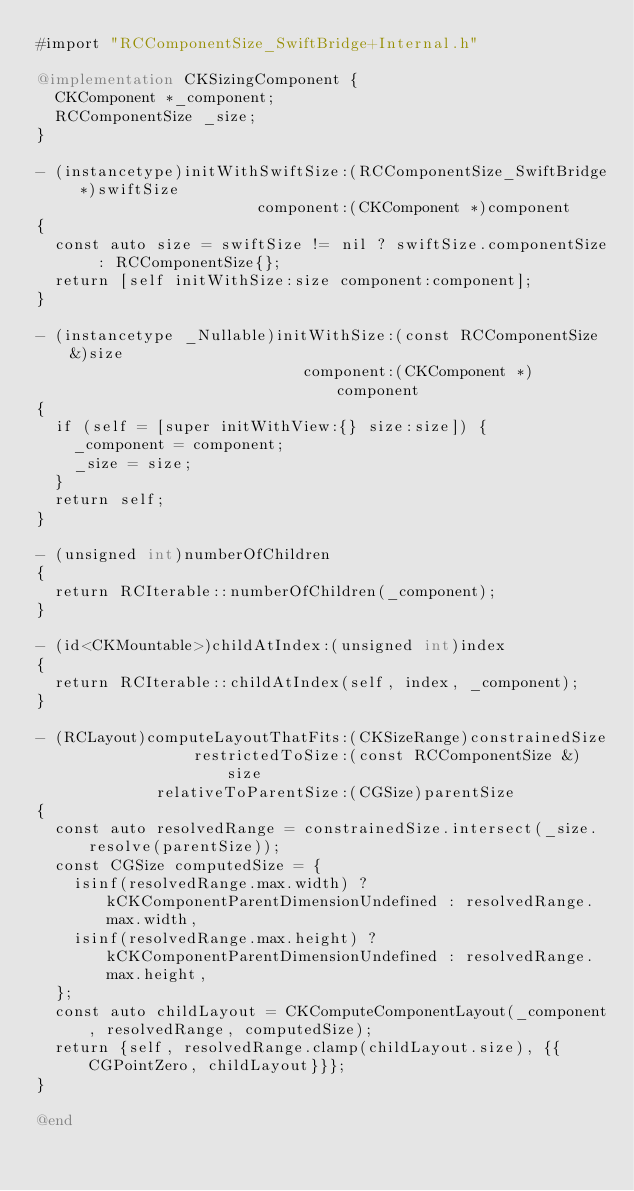<code> <loc_0><loc_0><loc_500><loc_500><_ObjectiveC_>#import "RCComponentSize_SwiftBridge+Internal.h"

@implementation CKSizingComponent {
  CKComponent *_component;
  RCComponentSize _size;
}

- (instancetype)initWithSwiftSize:(RCComponentSize_SwiftBridge *)swiftSize
                        component:(CKComponent *)component
{
  const auto size = swiftSize != nil ? swiftSize.componentSize : RCComponentSize{};
  return [self initWithSize:size component:component];
}

- (instancetype _Nullable)initWithSize:(const RCComponentSize &)size
                             component:(CKComponent *)component
{
  if (self = [super initWithView:{} size:size]) {
    _component = component;
    _size = size;
  }
  return self;
}

- (unsigned int)numberOfChildren
{
  return RCIterable::numberOfChildren(_component);
}

- (id<CKMountable>)childAtIndex:(unsigned int)index
{
  return RCIterable::childAtIndex(self, index, _component);
}

- (RCLayout)computeLayoutThatFits:(CKSizeRange)constrainedSize
                 restrictedToSize:(const RCComponentSize &)size
             relativeToParentSize:(CGSize)parentSize
{
  const auto resolvedRange = constrainedSize.intersect(_size.resolve(parentSize));
  const CGSize computedSize = {
    isinf(resolvedRange.max.width) ? kCKComponentParentDimensionUndefined : resolvedRange.max.width,
    isinf(resolvedRange.max.height) ? kCKComponentParentDimensionUndefined : resolvedRange.max.height,
  };
  const auto childLayout = CKComputeComponentLayout(_component, resolvedRange, computedSize);
  return {self, resolvedRange.clamp(childLayout.size), {{CGPointZero, childLayout}}};
}

@end
</code> 